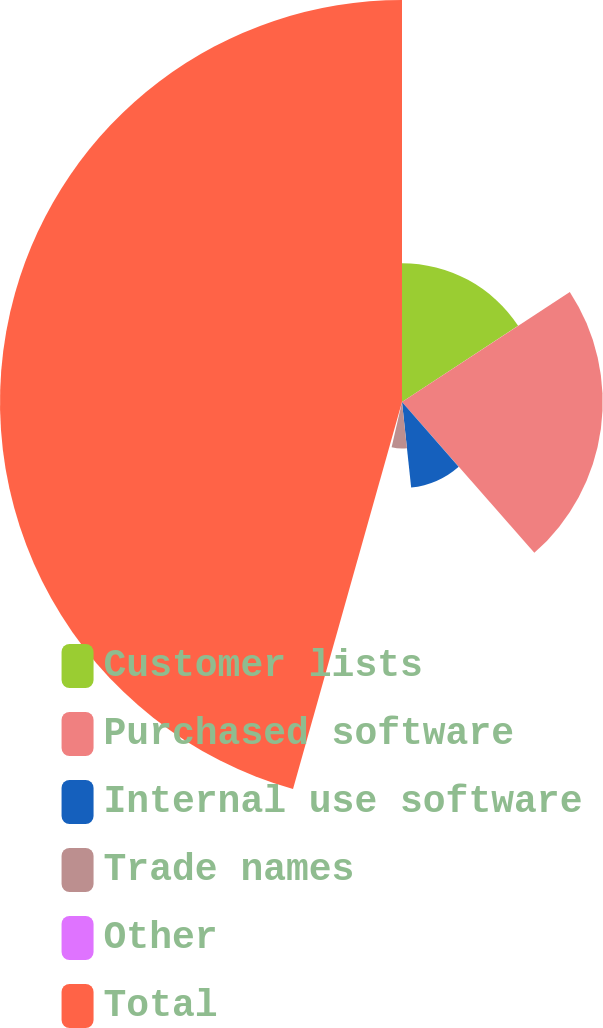Convert chart. <chart><loc_0><loc_0><loc_500><loc_500><pie_chart><fcel>Customer lists<fcel>Purchased software<fcel>Internal use software<fcel>Trade names<fcel>Other<fcel>Total<nl><fcel>15.76%<fcel>22.78%<fcel>9.76%<fcel>5.28%<fcel>0.79%<fcel>45.63%<nl></chart> 